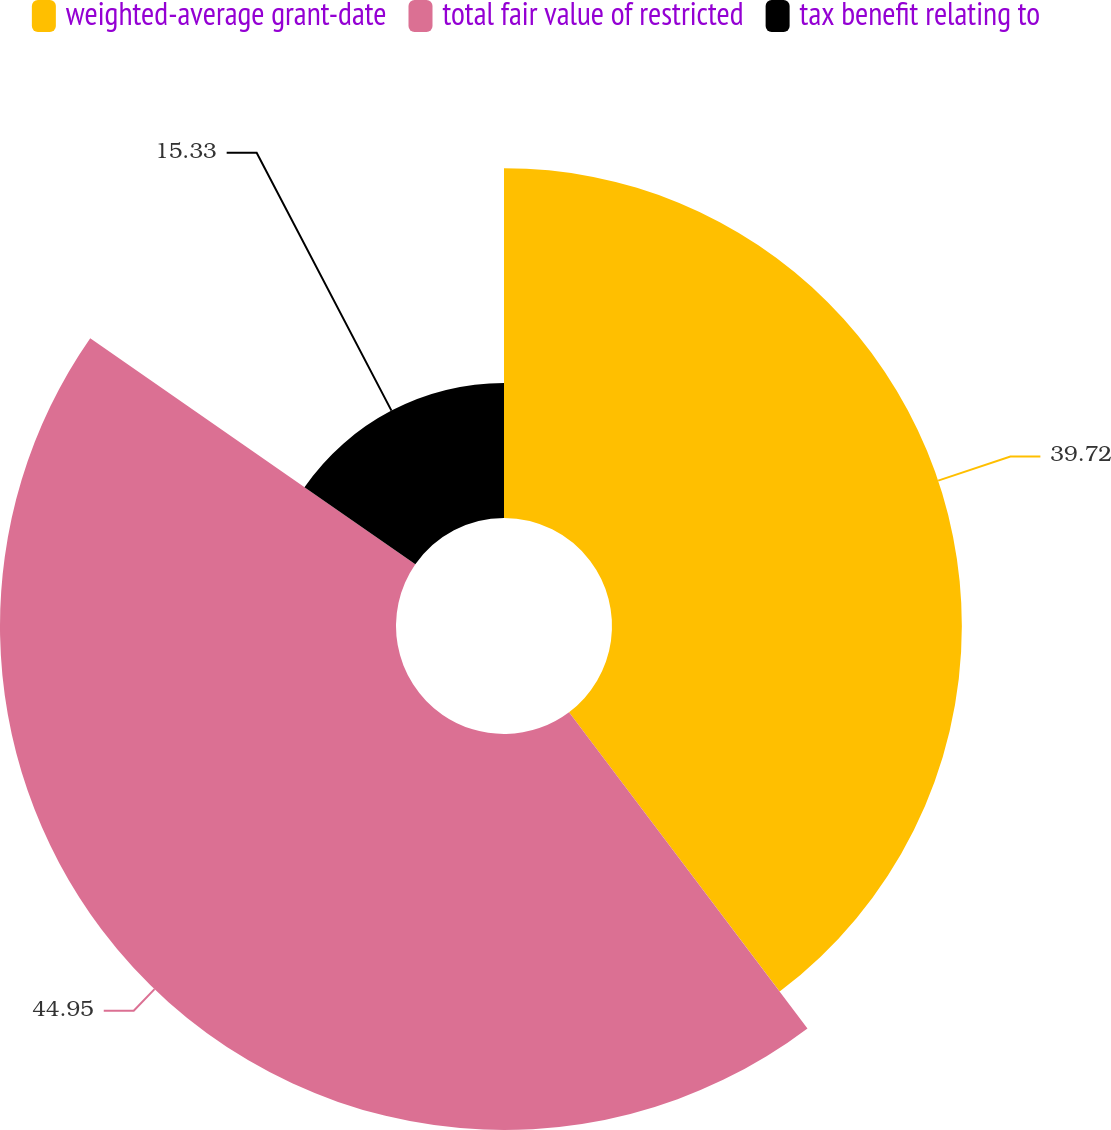<chart> <loc_0><loc_0><loc_500><loc_500><pie_chart><fcel>weighted-average grant-date<fcel>total fair value of restricted<fcel>tax benefit relating to<nl><fcel>39.72%<fcel>44.96%<fcel>15.33%<nl></chart> 